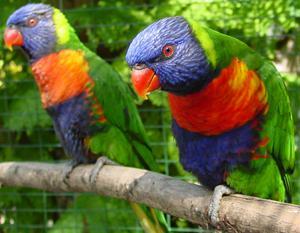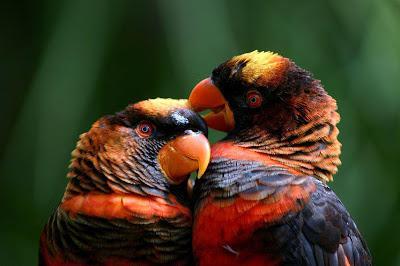The first image is the image on the left, the second image is the image on the right. For the images shown, is this caption "A single bird is perched on the edge of a bowl and facing left in one image." true? Answer yes or no. No. The first image is the image on the left, the second image is the image on the right. For the images shown, is this caption "There are 3 birds in the image pair" true? Answer yes or no. No. 